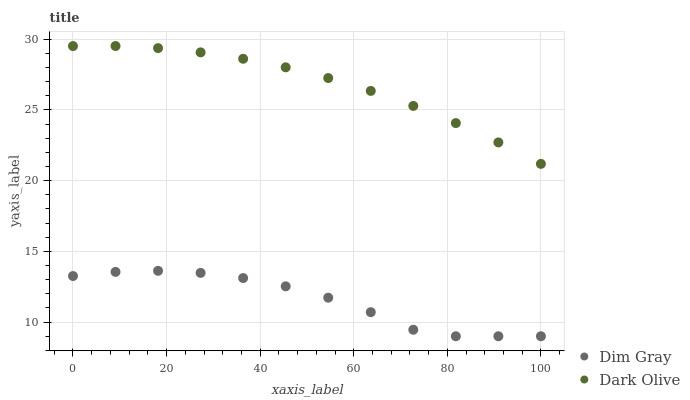Does Dim Gray have the minimum area under the curve?
Answer yes or no. Yes. Does Dark Olive have the maximum area under the curve?
Answer yes or no. Yes. Does Dim Gray have the maximum area under the curve?
Answer yes or no. No. Is Dark Olive the smoothest?
Answer yes or no. Yes. Is Dim Gray the roughest?
Answer yes or no. Yes. Is Dim Gray the smoothest?
Answer yes or no. No. Does Dim Gray have the lowest value?
Answer yes or no. Yes. Does Dark Olive have the highest value?
Answer yes or no. Yes. Does Dim Gray have the highest value?
Answer yes or no. No. Is Dim Gray less than Dark Olive?
Answer yes or no. Yes. Is Dark Olive greater than Dim Gray?
Answer yes or no. Yes. Does Dim Gray intersect Dark Olive?
Answer yes or no. No. 